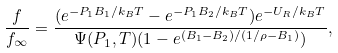<formula> <loc_0><loc_0><loc_500><loc_500>\frac { f } { f _ { \infty } } = \frac { ( e ^ { - P _ { 1 } B _ { 1 } / k _ { B } T } - e ^ { - P _ { 1 } B _ { 2 } / k _ { B } T } ) e ^ { - U _ { R } / k _ { B } T } } { \Psi ( P _ { 1 } , T ) ( 1 - e ^ { ( B _ { 1 } - B _ { 2 } ) / ( 1 / \rho - B _ { 1 } ) } ) } ,</formula> 